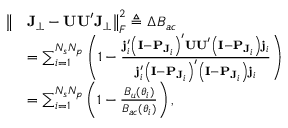Convert formula to latex. <formula><loc_0><loc_0><loc_500><loc_500>\begin{array} { r l } { \left \| } & { J _ { \perp } - U U ^ { \prime } J _ { \perp } \right \| _ { F } ^ { 2 } \triangle q \Delta B _ { a c } } \\ & { = \sum _ { i = 1 } ^ { N _ { s } N _ { p } } \left ( 1 - \frac { j _ { i } ^ { \prime } \left ( I - P _ { J _ { i } } \right ) ^ { \prime } U U ^ { \prime } \left ( I - P _ { J _ { i } } \right ) j _ { i } } { j _ { i } ^ { \prime } \left ( I - P _ { J _ { i } } \right ) ^ { \prime } \left ( I - P _ { J _ { i } } \right ) j _ { i } } \right ) } \\ & { = \sum _ { i = 1 } ^ { N _ { s } N _ { p } } \left ( 1 - \frac { B _ { u } ( \boldsymbol \theta _ { i } ) } { B _ { a c } ( \boldsymbol \theta _ { i } ) } \right ) , } \end{array}</formula> 